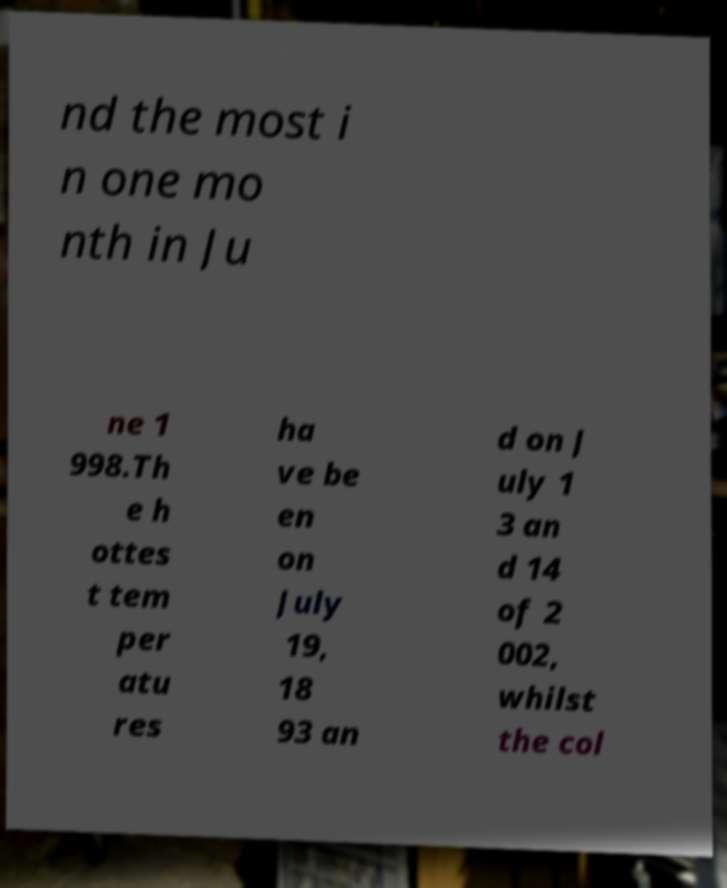Can you accurately transcribe the text from the provided image for me? nd the most i n one mo nth in Ju ne 1 998.Th e h ottes t tem per atu res ha ve be en on July 19, 18 93 an d on J uly 1 3 an d 14 of 2 002, whilst the col 